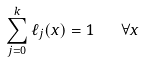<formula> <loc_0><loc_0><loc_500><loc_500>\sum _ { j = 0 } ^ { k } \ell _ { j } ( x ) = 1 \quad \forall x</formula> 